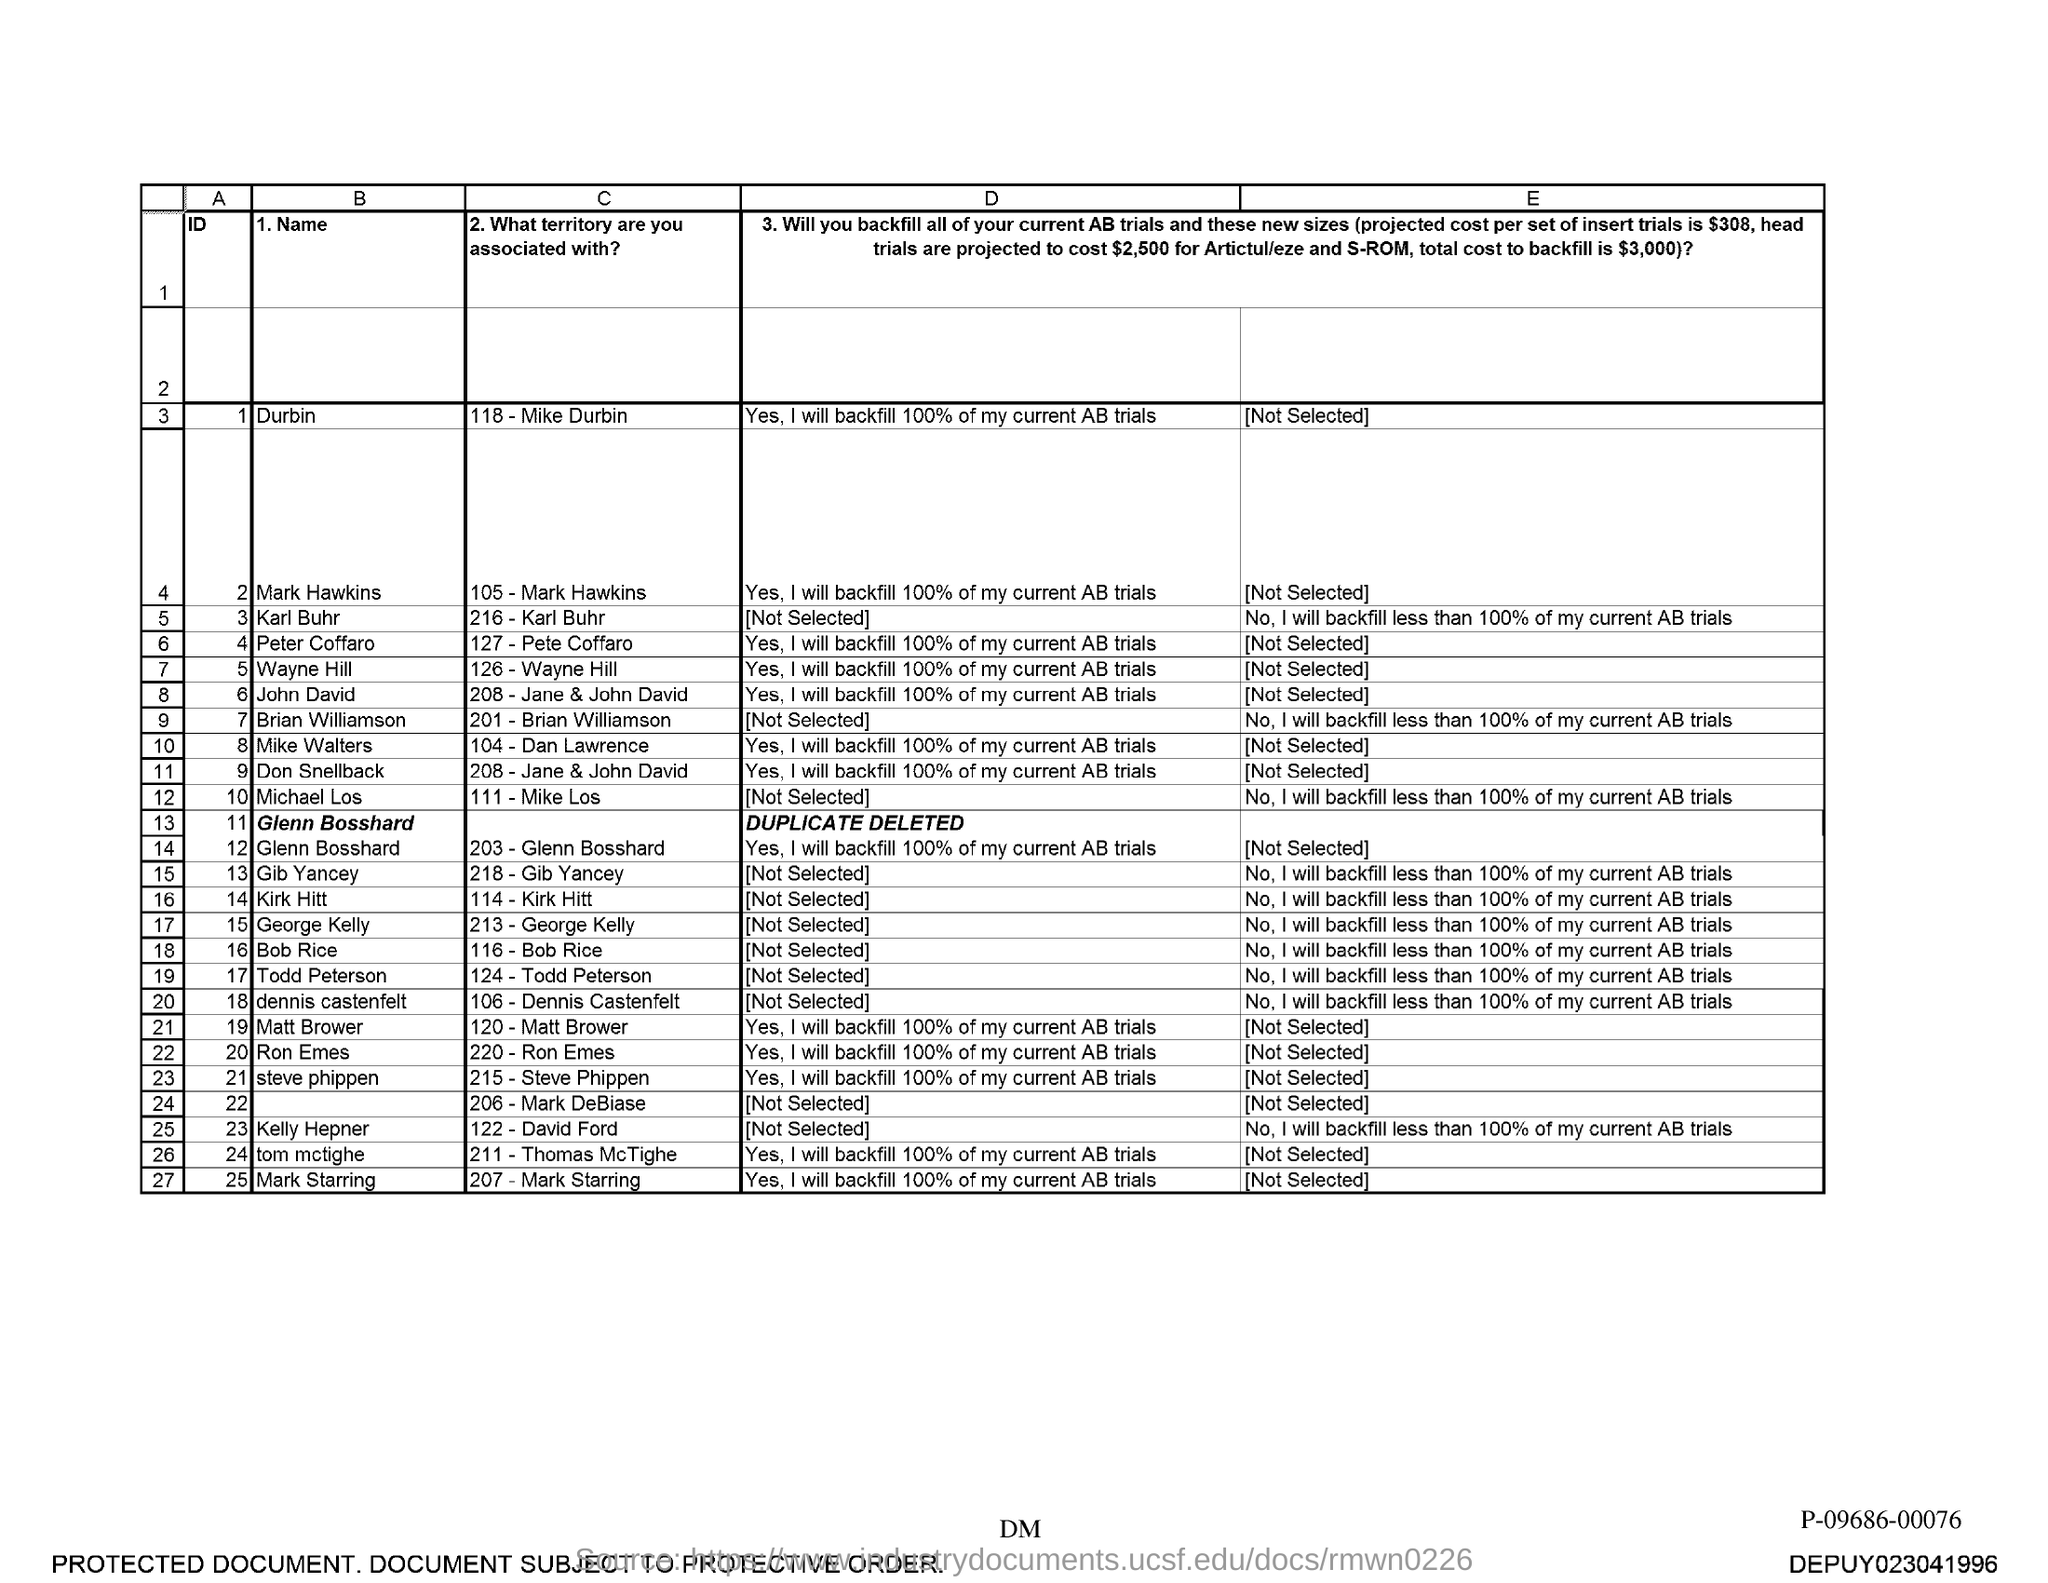What is the name associated with id 1?
Provide a succinct answer. Durbin. 